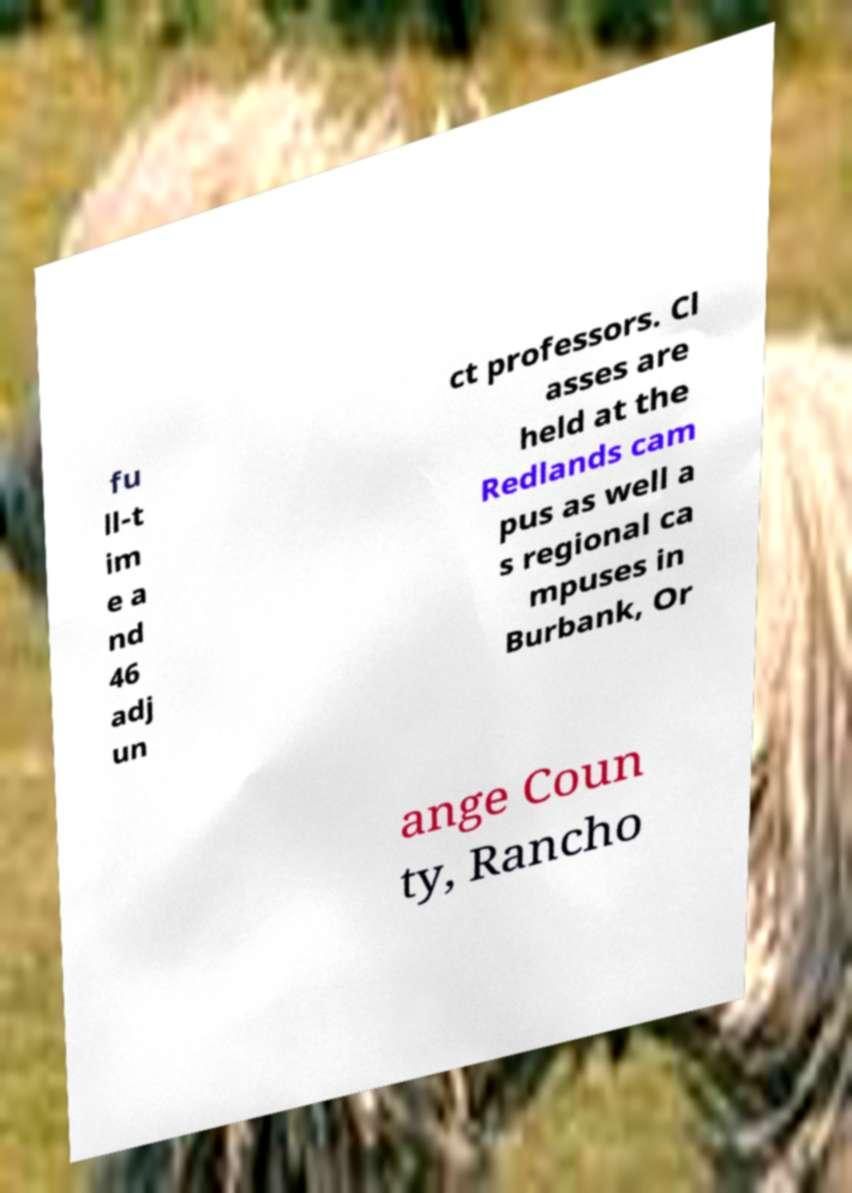What messages or text are displayed in this image? I need them in a readable, typed format. fu ll-t im e a nd 46 adj un ct professors. Cl asses are held at the Redlands cam pus as well a s regional ca mpuses in Burbank, Or ange Coun ty, Rancho 